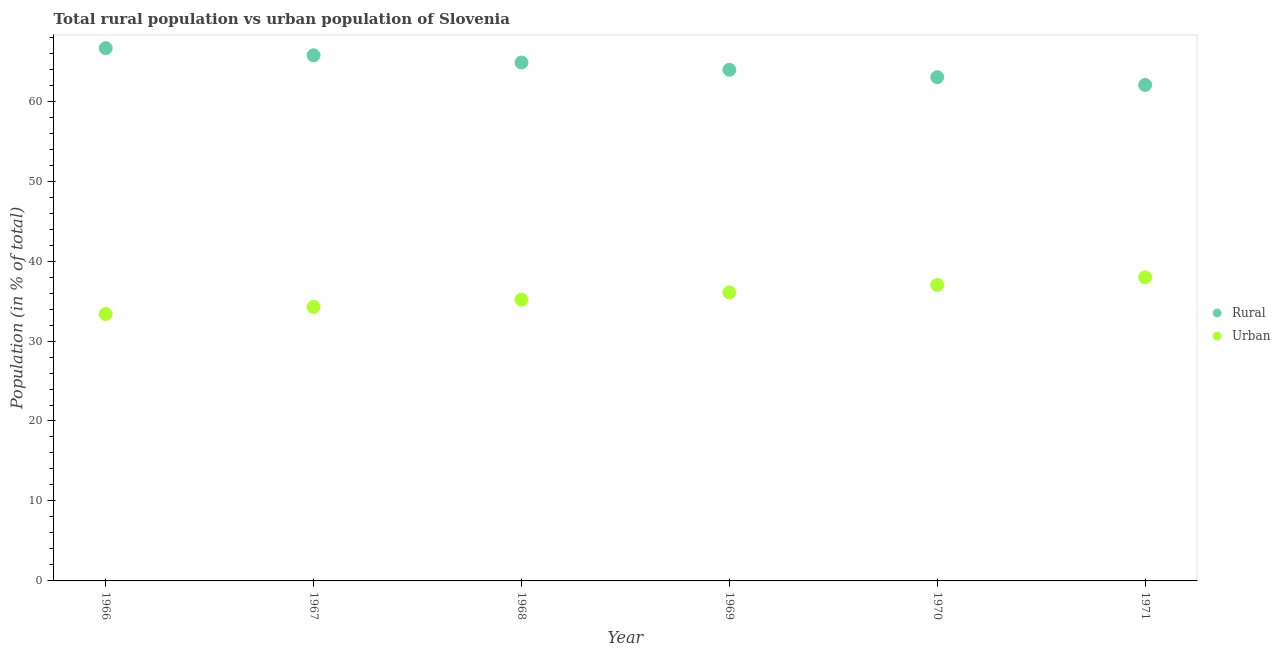What is the urban population in 1970?
Ensure brevity in your answer.  37. Across all years, what is the maximum urban population?
Give a very brief answer. 37.97. Across all years, what is the minimum urban population?
Make the answer very short. 33.38. In which year was the urban population minimum?
Offer a terse response. 1966. What is the total rural population in the graph?
Keep it short and to the point. 386.13. What is the difference between the urban population in 1966 and that in 1970?
Your answer should be very brief. -3.63. What is the difference between the urban population in 1968 and the rural population in 1970?
Offer a terse response. -27.83. What is the average urban population per year?
Keep it short and to the point. 35.64. In the year 1968, what is the difference between the urban population and rural population?
Offer a terse response. -29.66. What is the ratio of the urban population in 1968 to that in 1969?
Keep it short and to the point. 0.97. Is the urban population in 1968 less than that in 1971?
Provide a short and direct response. Yes. Is the difference between the rural population in 1968 and 1971 greater than the difference between the urban population in 1968 and 1971?
Your response must be concise. Yes. What is the difference between the highest and the second highest rural population?
Offer a terse response. 0.89. What is the difference between the highest and the lowest urban population?
Make the answer very short. 4.6. In how many years, is the rural population greater than the average rural population taken over all years?
Offer a very short reply. 3. Does the urban population monotonically increase over the years?
Provide a succinct answer. Yes. Are the values on the major ticks of Y-axis written in scientific E-notation?
Give a very brief answer. No. Does the graph contain grids?
Provide a short and direct response. No. Where does the legend appear in the graph?
Your response must be concise. Center right. How are the legend labels stacked?
Keep it short and to the point. Vertical. What is the title of the graph?
Offer a very short reply. Total rural population vs urban population of Slovenia. Does "Investment" appear as one of the legend labels in the graph?
Offer a very short reply. No. What is the label or title of the X-axis?
Provide a short and direct response. Year. What is the label or title of the Y-axis?
Give a very brief answer. Population (in % of total). What is the Population (in % of total) in Rural in 1966?
Your response must be concise. 66.62. What is the Population (in % of total) of Urban in 1966?
Provide a short and direct response. 33.38. What is the Population (in % of total) of Rural in 1967?
Keep it short and to the point. 65.73. What is the Population (in % of total) in Urban in 1967?
Give a very brief answer. 34.27. What is the Population (in % of total) of Rural in 1968?
Your response must be concise. 64.83. What is the Population (in % of total) of Urban in 1968?
Your answer should be compact. 35.17. What is the Population (in % of total) of Rural in 1969?
Your response must be concise. 63.92. What is the Population (in % of total) in Urban in 1969?
Ensure brevity in your answer.  36.08. What is the Population (in % of total) in Rural in 1970?
Your answer should be very brief. 63. What is the Population (in % of total) of Urban in 1970?
Make the answer very short. 37. What is the Population (in % of total) in Rural in 1971?
Your answer should be very brief. 62.03. What is the Population (in % of total) in Urban in 1971?
Your answer should be compact. 37.97. Across all years, what is the maximum Population (in % of total) in Rural?
Your response must be concise. 66.62. Across all years, what is the maximum Population (in % of total) in Urban?
Your answer should be very brief. 37.97. Across all years, what is the minimum Population (in % of total) in Rural?
Your answer should be compact. 62.03. Across all years, what is the minimum Population (in % of total) in Urban?
Make the answer very short. 33.38. What is the total Population (in % of total) in Rural in the graph?
Provide a succinct answer. 386.13. What is the total Population (in % of total) in Urban in the graph?
Offer a terse response. 213.87. What is the difference between the Population (in % of total) in Rural in 1966 and that in 1967?
Keep it short and to the point. 0.89. What is the difference between the Population (in % of total) in Urban in 1966 and that in 1967?
Keep it short and to the point. -0.89. What is the difference between the Population (in % of total) in Rural in 1966 and that in 1968?
Your response must be concise. 1.79. What is the difference between the Population (in % of total) in Urban in 1966 and that in 1968?
Give a very brief answer. -1.79. What is the difference between the Population (in % of total) of Rural in 1966 and that in 1969?
Your answer should be compact. 2.71. What is the difference between the Population (in % of total) of Urban in 1966 and that in 1969?
Your answer should be very brief. -2.71. What is the difference between the Population (in % of total) in Rural in 1966 and that in 1970?
Give a very brief answer. 3.63. What is the difference between the Population (in % of total) in Urban in 1966 and that in 1970?
Give a very brief answer. -3.63. What is the difference between the Population (in % of total) of Rural in 1966 and that in 1971?
Give a very brief answer. 4.6. What is the difference between the Population (in % of total) in Urban in 1966 and that in 1971?
Your response must be concise. -4.6. What is the difference between the Population (in % of total) in Rural in 1967 and that in 1968?
Make the answer very short. 0.9. What is the difference between the Population (in % of total) in Urban in 1967 and that in 1968?
Ensure brevity in your answer.  -0.9. What is the difference between the Population (in % of total) of Rural in 1967 and that in 1969?
Offer a very short reply. 1.81. What is the difference between the Population (in % of total) of Urban in 1967 and that in 1969?
Offer a very short reply. -1.81. What is the difference between the Population (in % of total) of Rural in 1967 and that in 1970?
Your answer should be very brief. 2.74. What is the difference between the Population (in % of total) in Urban in 1967 and that in 1970?
Offer a very short reply. -2.74. What is the difference between the Population (in % of total) of Rural in 1967 and that in 1971?
Give a very brief answer. 3.71. What is the difference between the Population (in % of total) of Urban in 1967 and that in 1971?
Give a very brief answer. -3.71. What is the difference between the Population (in % of total) of Rural in 1968 and that in 1969?
Make the answer very short. 0.91. What is the difference between the Population (in % of total) of Urban in 1968 and that in 1969?
Provide a succinct answer. -0.91. What is the difference between the Population (in % of total) of Rural in 1968 and that in 1970?
Make the answer very short. 1.83. What is the difference between the Population (in % of total) in Urban in 1968 and that in 1970?
Give a very brief answer. -1.83. What is the difference between the Population (in % of total) of Rural in 1968 and that in 1971?
Offer a terse response. 2.8. What is the difference between the Population (in % of total) of Urban in 1968 and that in 1971?
Your answer should be very brief. -2.8. What is the difference between the Population (in % of total) in Rural in 1969 and that in 1970?
Offer a very short reply. 0.92. What is the difference between the Population (in % of total) in Urban in 1969 and that in 1970?
Offer a terse response. -0.92. What is the difference between the Population (in % of total) in Rural in 1969 and that in 1971?
Make the answer very short. 1.89. What is the difference between the Population (in % of total) in Urban in 1969 and that in 1971?
Provide a short and direct response. -1.89. What is the difference between the Population (in % of total) in Urban in 1970 and that in 1971?
Make the answer very short. -0.97. What is the difference between the Population (in % of total) in Rural in 1966 and the Population (in % of total) in Urban in 1967?
Offer a terse response. 32.36. What is the difference between the Population (in % of total) of Rural in 1966 and the Population (in % of total) of Urban in 1968?
Ensure brevity in your answer.  31.45. What is the difference between the Population (in % of total) of Rural in 1966 and the Population (in % of total) of Urban in 1969?
Keep it short and to the point. 30.54. What is the difference between the Population (in % of total) of Rural in 1966 and the Population (in % of total) of Urban in 1970?
Provide a short and direct response. 29.62. What is the difference between the Population (in % of total) of Rural in 1966 and the Population (in % of total) of Urban in 1971?
Keep it short and to the point. 28.65. What is the difference between the Population (in % of total) in Rural in 1967 and the Population (in % of total) in Urban in 1968?
Your response must be concise. 30.57. What is the difference between the Population (in % of total) in Rural in 1967 and the Population (in % of total) in Urban in 1969?
Your answer should be very brief. 29.65. What is the difference between the Population (in % of total) in Rural in 1967 and the Population (in % of total) in Urban in 1970?
Provide a short and direct response. 28.73. What is the difference between the Population (in % of total) of Rural in 1967 and the Population (in % of total) of Urban in 1971?
Provide a short and direct response. 27.76. What is the difference between the Population (in % of total) of Rural in 1968 and the Population (in % of total) of Urban in 1969?
Make the answer very short. 28.75. What is the difference between the Population (in % of total) in Rural in 1968 and the Population (in % of total) in Urban in 1970?
Provide a succinct answer. 27.83. What is the difference between the Population (in % of total) in Rural in 1968 and the Population (in % of total) in Urban in 1971?
Offer a terse response. 26.86. What is the difference between the Population (in % of total) of Rural in 1969 and the Population (in % of total) of Urban in 1970?
Your answer should be very brief. 26.91. What is the difference between the Population (in % of total) of Rural in 1969 and the Population (in % of total) of Urban in 1971?
Your answer should be very brief. 25.95. What is the difference between the Population (in % of total) of Rural in 1970 and the Population (in % of total) of Urban in 1971?
Ensure brevity in your answer.  25.02. What is the average Population (in % of total) of Rural per year?
Make the answer very short. 64.36. What is the average Population (in % of total) of Urban per year?
Offer a very short reply. 35.64. In the year 1966, what is the difference between the Population (in % of total) in Rural and Population (in % of total) in Urban?
Offer a very short reply. 33.25. In the year 1967, what is the difference between the Population (in % of total) in Rural and Population (in % of total) in Urban?
Your response must be concise. 31.47. In the year 1968, what is the difference between the Population (in % of total) of Rural and Population (in % of total) of Urban?
Offer a terse response. 29.66. In the year 1969, what is the difference between the Population (in % of total) of Rural and Population (in % of total) of Urban?
Your answer should be very brief. 27.84. In the year 1970, what is the difference between the Population (in % of total) in Rural and Population (in % of total) in Urban?
Keep it short and to the point. 25.99. In the year 1971, what is the difference between the Population (in % of total) of Rural and Population (in % of total) of Urban?
Your response must be concise. 24.06. What is the ratio of the Population (in % of total) of Rural in 1966 to that in 1967?
Offer a very short reply. 1.01. What is the ratio of the Population (in % of total) in Urban in 1966 to that in 1967?
Provide a short and direct response. 0.97. What is the ratio of the Population (in % of total) in Rural in 1966 to that in 1968?
Keep it short and to the point. 1.03. What is the ratio of the Population (in % of total) in Urban in 1966 to that in 1968?
Give a very brief answer. 0.95. What is the ratio of the Population (in % of total) of Rural in 1966 to that in 1969?
Your answer should be very brief. 1.04. What is the ratio of the Population (in % of total) in Urban in 1966 to that in 1969?
Make the answer very short. 0.93. What is the ratio of the Population (in % of total) of Rural in 1966 to that in 1970?
Offer a very short reply. 1.06. What is the ratio of the Population (in % of total) in Urban in 1966 to that in 1970?
Your response must be concise. 0.9. What is the ratio of the Population (in % of total) in Rural in 1966 to that in 1971?
Your answer should be very brief. 1.07. What is the ratio of the Population (in % of total) of Urban in 1966 to that in 1971?
Your response must be concise. 0.88. What is the ratio of the Population (in % of total) in Rural in 1967 to that in 1968?
Ensure brevity in your answer.  1.01. What is the ratio of the Population (in % of total) in Urban in 1967 to that in 1968?
Your answer should be very brief. 0.97. What is the ratio of the Population (in % of total) in Rural in 1967 to that in 1969?
Ensure brevity in your answer.  1.03. What is the ratio of the Population (in % of total) in Urban in 1967 to that in 1969?
Ensure brevity in your answer.  0.95. What is the ratio of the Population (in % of total) of Rural in 1967 to that in 1970?
Offer a very short reply. 1.04. What is the ratio of the Population (in % of total) in Urban in 1967 to that in 1970?
Provide a succinct answer. 0.93. What is the ratio of the Population (in % of total) of Rural in 1967 to that in 1971?
Your response must be concise. 1.06. What is the ratio of the Population (in % of total) in Urban in 1967 to that in 1971?
Provide a succinct answer. 0.9. What is the ratio of the Population (in % of total) of Rural in 1968 to that in 1969?
Your response must be concise. 1.01. What is the ratio of the Population (in % of total) of Urban in 1968 to that in 1969?
Provide a short and direct response. 0.97. What is the ratio of the Population (in % of total) of Rural in 1968 to that in 1970?
Offer a terse response. 1.03. What is the ratio of the Population (in % of total) of Urban in 1968 to that in 1970?
Give a very brief answer. 0.95. What is the ratio of the Population (in % of total) in Rural in 1968 to that in 1971?
Your response must be concise. 1.05. What is the ratio of the Population (in % of total) of Urban in 1968 to that in 1971?
Ensure brevity in your answer.  0.93. What is the ratio of the Population (in % of total) of Rural in 1969 to that in 1970?
Provide a short and direct response. 1.01. What is the ratio of the Population (in % of total) in Urban in 1969 to that in 1970?
Offer a very short reply. 0.98. What is the ratio of the Population (in % of total) of Rural in 1969 to that in 1971?
Your answer should be very brief. 1.03. What is the ratio of the Population (in % of total) of Urban in 1969 to that in 1971?
Your answer should be very brief. 0.95. What is the ratio of the Population (in % of total) in Rural in 1970 to that in 1971?
Keep it short and to the point. 1.02. What is the ratio of the Population (in % of total) of Urban in 1970 to that in 1971?
Keep it short and to the point. 0.97. What is the difference between the highest and the second highest Population (in % of total) in Rural?
Provide a succinct answer. 0.89. What is the difference between the highest and the lowest Population (in % of total) of Rural?
Offer a very short reply. 4.6. What is the difference between the highest and the lowest Population (in % of total) in Urban?
Ensure brevity in your answer.  4.6. 